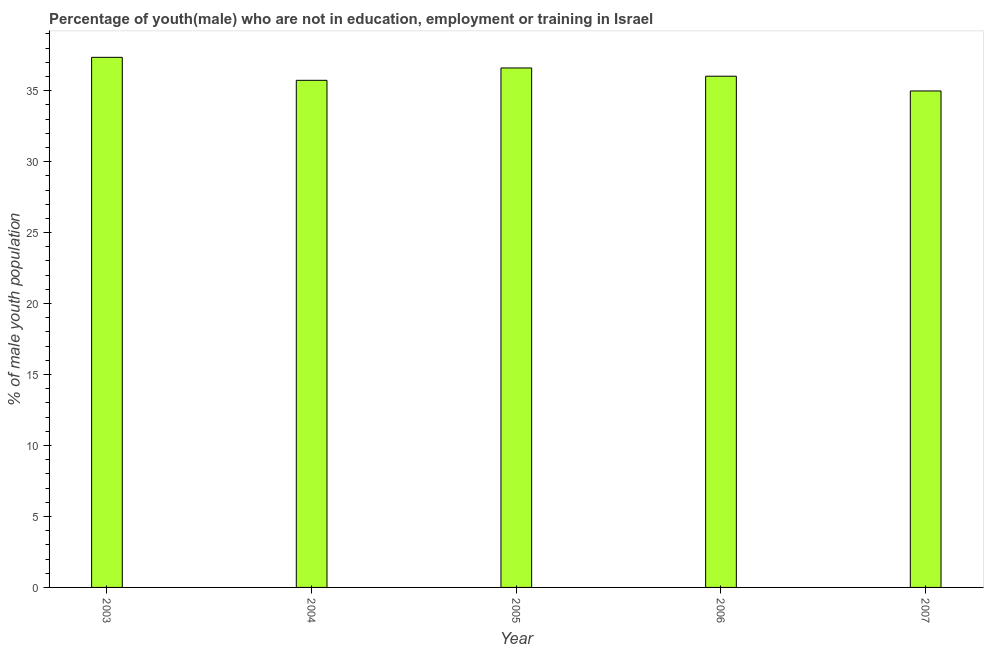Does the graph contain any zero values?
Give a very brief answer. No. Does the graph contain grids?
Make the answer very short. No. What is the title of the graph?
Make the answer very short. Percentage of youth(male) who are not in education, employment or training in Israel. What is the label or title of the X-axis?
Offer a terse response. Year. What is the label or title of the Y-axis?
Make the answer very short. % of male youth population. What is the unemployed male youth population in 2007?
Give a very brief answer. 34.98. Across all years, what is the maximum unemployed male youth population?
Provide a succinct answer. 37.35. Across all years, what is the minimum unemployed male youth population?
Give a very brief answer. 34.98. In which year was the unemployed male youth population maximum?
Your response must be concise. 2003. What is the sum of the unemployed male youth population?
Your answer should be very brief. 180.68. What is the average unemployed male youth population per year?
Your response must be concise. 36.14. What is the median unemployed male youth population?
Your answer should be compact. 36.02. In how many years, is the unemployed male youth population greater than 9 %?
Your answer should be very brief. 5. What is the ratio of the unemployed male youth population in 2003 to that in 2004?
Ensure brevity in your answer.  1.04. Is the unemployed male youth population in 2004 less than that in 2007?
Ensure brevity in your answer.  No. Is the difference between the unemployed male youth population in 2004 and 2006 greater than the difference between any two years?
Provide a succinct answer. No. What is the difference between the highest and the second highest unemployed male youth population?
Your answer should be compact. 0.75. Is the sum of the unemployed male youth population in 2003 and 2006 greater than the maximum unemployed male youth population across all years?
Provide a short and direct response. Yes. What is the difference between the highest and the lowest unemployed male youth population?
Your response must be concise. 2.37. In how many years, is the unemployed male youth population greater than the average unemployed male youth population taken over all years?
Ensure brevity in your answer.  2. How many bars are there?
Ensure brevity in your answer.  5. Are the values on the major ticks of Y-axis written in scientific E-notation?
Give a very brief answer. No. What is the % of male youth population in 2003?
Keep it short and to the point. 37.35. What is the % of male youth population of 2004?
Provide a short and direct response. 35.73. What is the % of male youth population of 2005?
Keep it short and to the point. 36.6. What is the % of male youth population of 2006?
Make the answer very short. 36.02. What is the % of male youth population in 2007?
Your answer should be very brief. 34.98. What is the difference between the % of male youth population in 2003 and 2004?
Your response must be concise. 1.62. What is the difference between the % of male youth population in 2003 and 2006?
Offer a terse response. 1.33. What is the difference between the % of male youth population in 2003 and 2007?
Your response must be concise. 2.37. What is the difference between the % of male youth population in 2004 and 2005?
Keep it short and to the point. -0.87. What is the difference between the % of male youth population in 2004 and 2006?
Your answer should be compact. -0.29. What is the difference between the % of male youth population in 2005 and 2006?
Offer a terse response. 0.58. What is the difference between the % of male youth population in 2005 and 2007?
Your answer should be very brief. 1.62. What is the difference between the % of male youth population in 2006 and 2007?
Make the answer very short. 1.04. What is the ratio of the % of male youth population in 2003 to that in 2004?
Your response must be concise. 1.04. What is the ratio of the % of male youth population in 2003 to that in 2005?
Provide a succinct answer. 1.02. What is the ratio of the % of male youth population in 2003 to that in 2007?
Your answer should be very brief. 1.07. What is the ratio of the % of male youth population in 2004 to that in 2005?
Give a very brief answer. 0.98. What is the ratio of the % of male youth population in 2004 to that in 2007?
Offer a very short reply. 1.02. What is the ratio of the % of male youth population in 2005 to that in 2006?
Ensure brevity in your answer.  1.02. What is the ratio of the % of male youth population in 2005 to that in 2007?
Make the answer very short. 1.05. What is the ratio of the % of male youth population in 2006 to that in 2007?
Offer a very short reply. 1.03. 